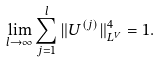Convert formula to latex. <formula><loc_0><loc_0><loc_500><loc_500>\lim _ { l \rightarrow \infty } \sum _ { j = 1 } ^ { l } \| U ^ { ( j ) } \| _ { L ^ { V } } ^ { 4 } = 1 .</formula> 